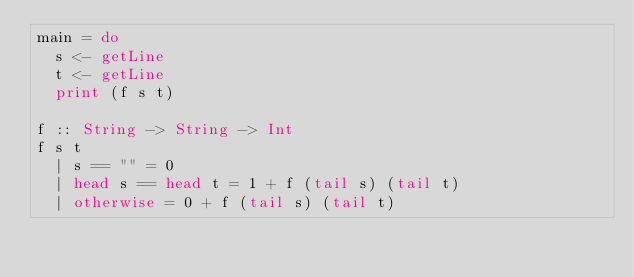Convert code to text. <code><loc_0><loc_0><loc_500><loc_500><_Haskell_>main = do
  s <- getLine
  t <- getLine
  print (f s t)

f :: String -> String -> Int
f s t
  | s == "" = 0
  | head s == head t = 1 + f (tail s) (tail t)
  | otherwise = 0 + f (tail s) (tail t)
</code> 